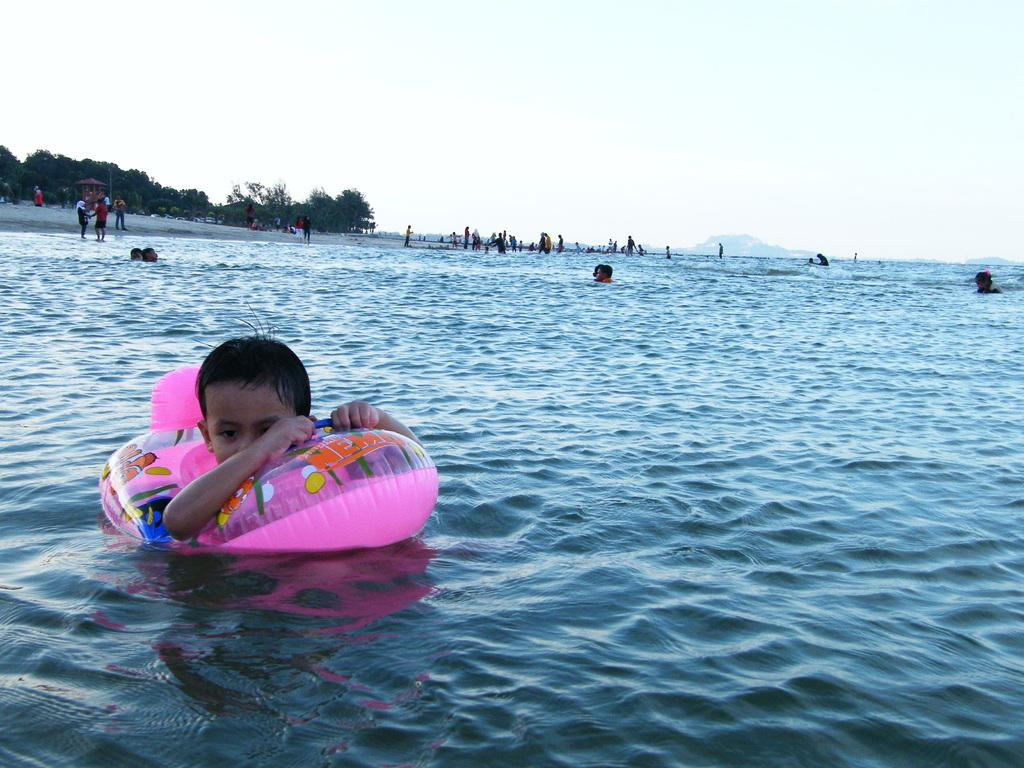What is the main element in the image? There is water in the image. What are the people in the water doing? There are people swimming in the water. What type of vegetation can be seen on the left side of the image? There are trees on the left side of the image. What is visible at the top of the image? The sky is visible at the top of the image. What type of suit is the person wearing while exchanging selections in the image? There is no person wearing a suit or exchanging selections in the image; it features people swimming in water with trees and the sky visible. 